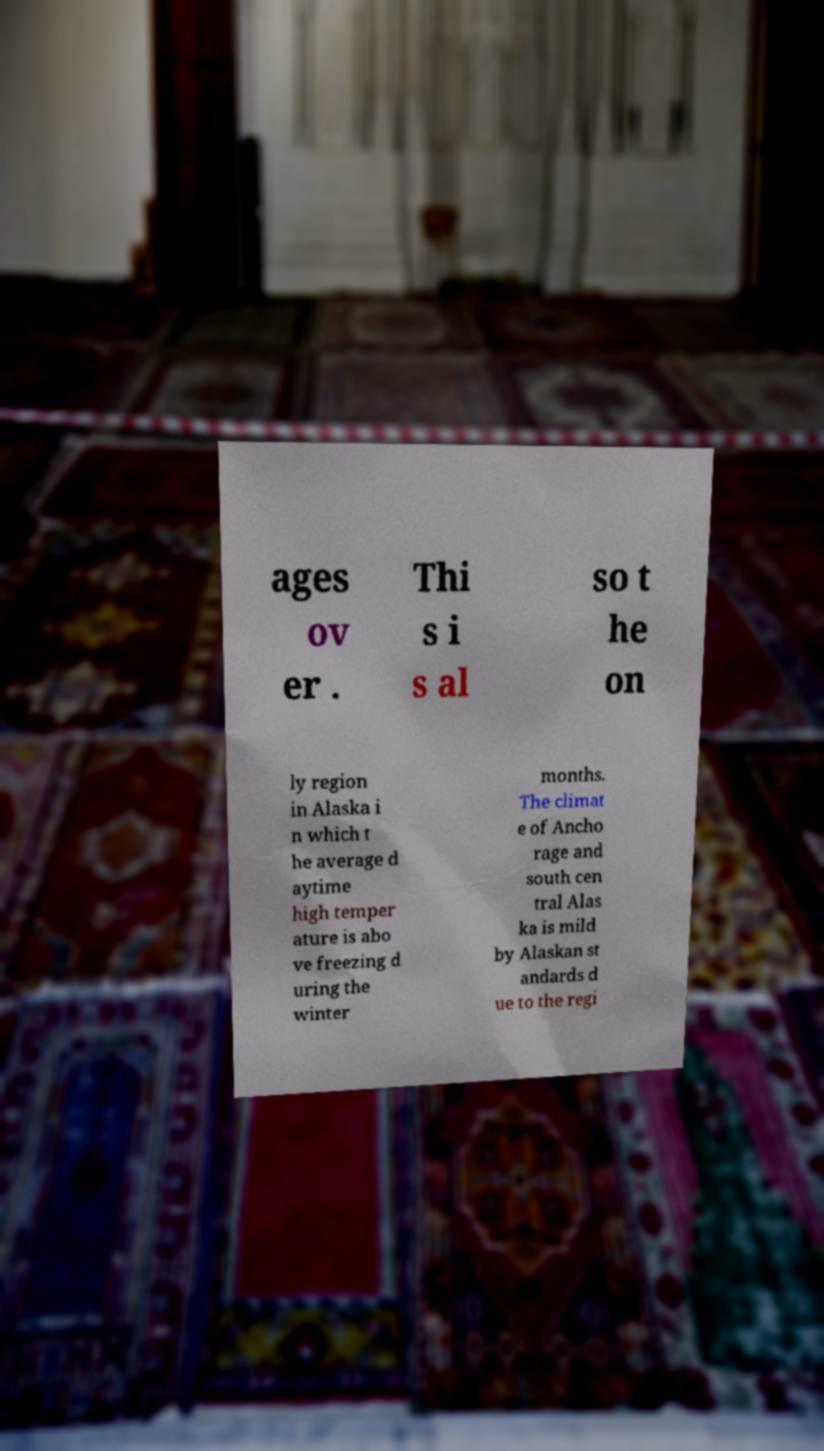Could you assist in decoding the text presented in this image and type it out clearly? ages ov er . Thi s i s al so t he on ly region in Alaska i n which t he average d aytime high temper ature is abo ve freezing d uring the winter months. The climat e of Ancho rage and south cen tral Alas ka is mild by Alaskan st andards d ue to the regi 